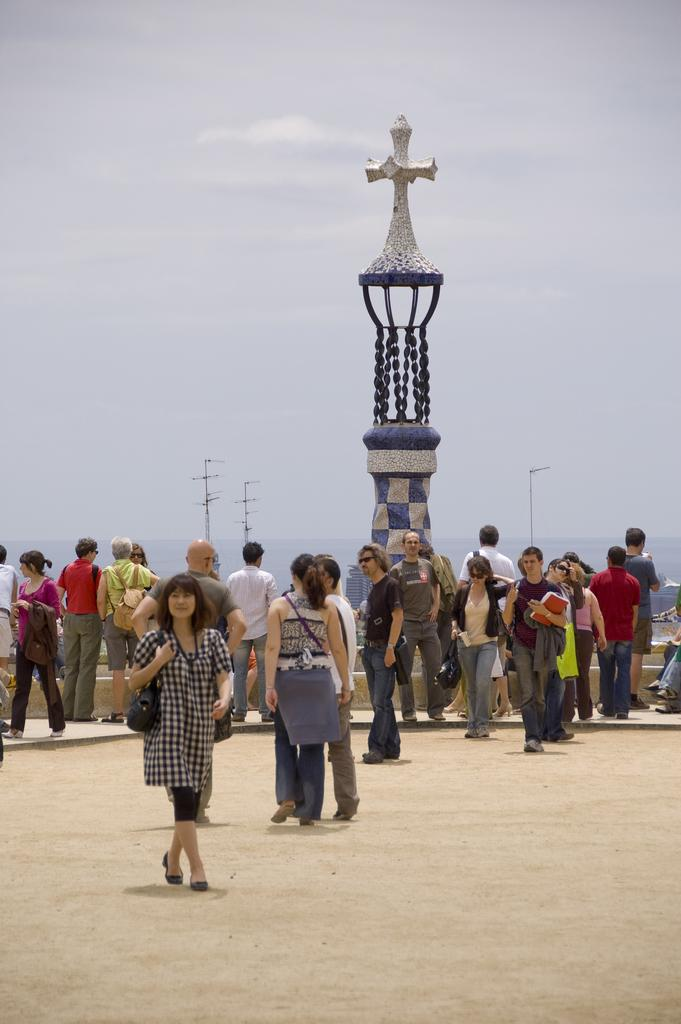What type of surface is visible in the image? There is ground visible in the image. What are the people in the image doing? The people are standing on the ground. What can be seen in the background of the image? There is a tower, poles, water, and the sky visible in the background of the image. What type of shoes are the people wearing in the image? There is no information about shoes in the image. 